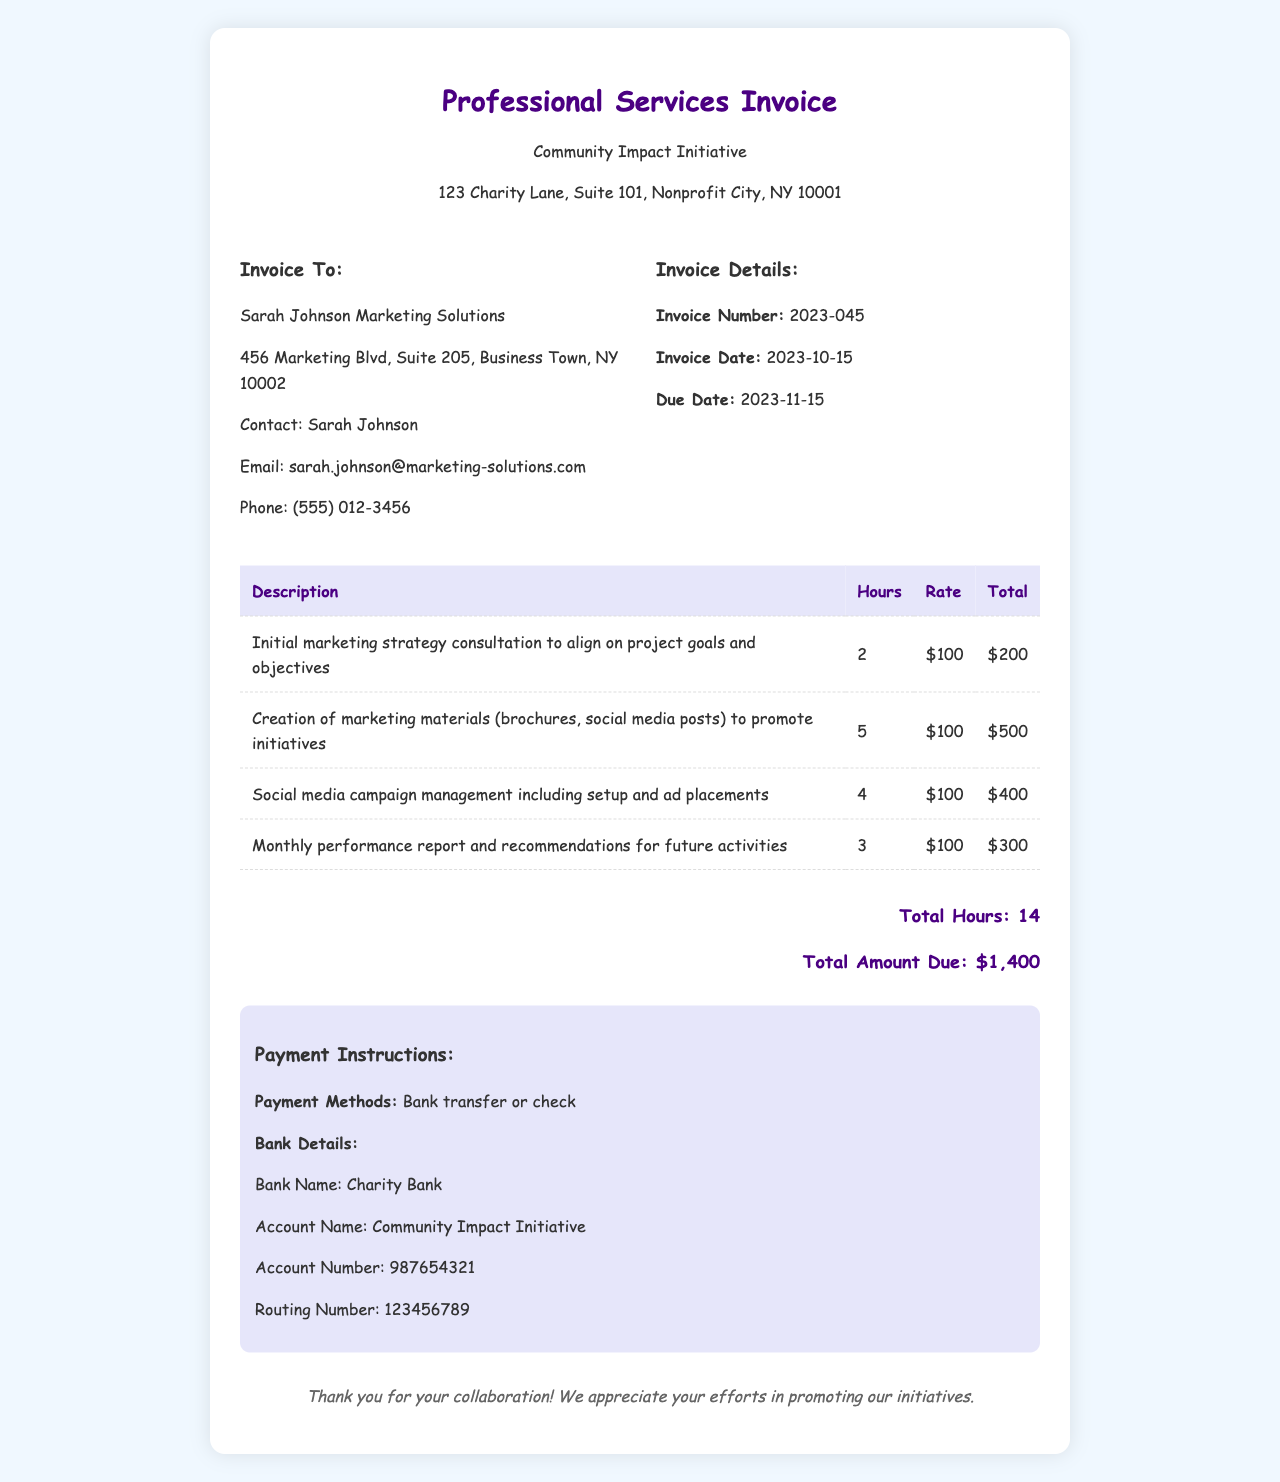What is the total amount due? The total amount due is clearly stated at the bottom of the invoice as $1,400.
Answer: $1,400 What is the invoice date? The invoice date is provided in the invoice details section, noted as 2023-10-15.
Answer: 2023-10-15 Who is the contact at Sarah Johnson Marketing Solutions? The contact name is listed under the invoice recipient information as Sarah Johnson.
Answer: Sarah Johnson How many total hours were billed? Total hours are summarized at the bottom of the invoice, amounting to 14 hours.
Answer: 14 What is the description of the first service rendered? The first service rendered is described as "Initial marketing strategy consultation to align on project goals and objectives."
Answer: Initial marketing strategy consultation to align on project goals and objectives What is the rate charged per hour for services? The rate is the same for all services and is noted as $100 per hour.
Answer: $100 What is the due date for this invoice? The due date is specified in the invoice details as 2023-11-15.
Answer: 2023-11-15 What payment methods are accepted? The accepted payment methods are stated as "Bank transfer or check."
Answer: Bank transfer or check What is the total for "Social media campaign management"? The total for that service is clearly listed in the invoice as $400.
Answer: $400 